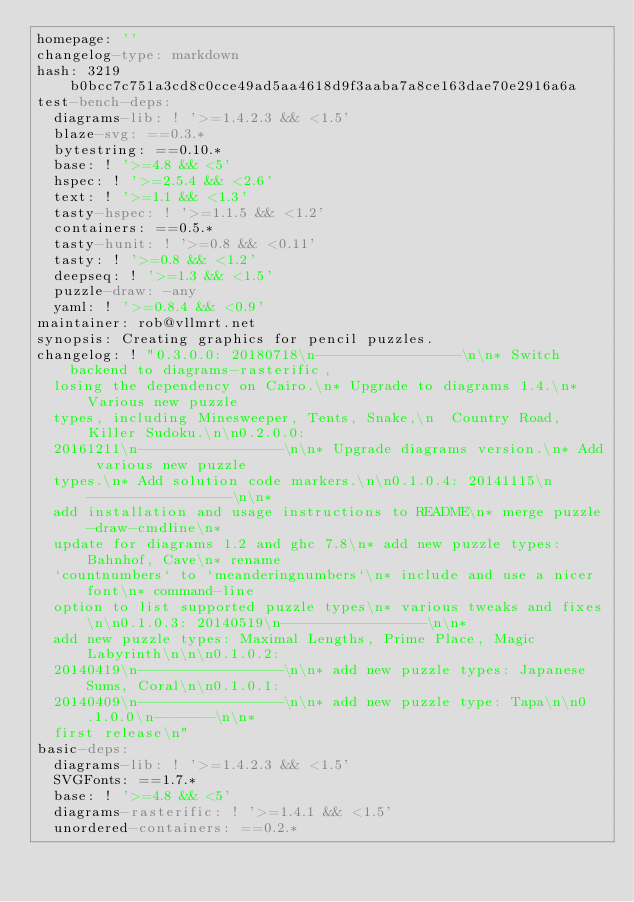Convert code to text. <code><loc_0><loc_0><loc_500><loc_500><_YAML_>homepage: ''
changelog-type: markdown
hash: 3219b0bcc7c751a3cd8c0cce49ad5aa4618d9f3aaba7a8ce163dae70e2916a6a
test-bench-deps:
  diagrams-lib: ! '>=1.4.2.3 && <1.5'
  blaze-svg: ==0.3.*
  bytestring: ==0.10.*
  base: ! '>=4.8 && <5'
  hspec: ! '>=2.5.4 && <2.6'
  text: ! '>=1.1 && <1.3'
  tasty-hspec: ! '>=1.1.5 && <1.2'
  containers: ==0.5.*
  tasty-hunit: ! '>=0.8 && <0.11'
  tasty: ! '>=0.8 && <1.2'
  deepseq: ! '>=1.3 && <1.5'
  puzzle-draw: -any
  yaml: ! '>=0.8.4 && <0.9'
maintainer: rob@vllmrt.net
synopsis: Creating graphics for pencil puzzles.
changelog: ! "0.3.0.0: 20180718\n-----------------\n\n* Switch backend to diagrams-rasterific,
  losing the dependency on Cairo.\n* Upgrade to diagrams 1.4.\n* Various new puzzle
  types, including Minesweeper, Tents, Snake,\n  Country Road, Killer Sudoku.\n\n0.2.0.0:
  20161211\n-----------------\n\n* Upgrade diagrams version.\n* Add various new puzzle
  types.\n* Add solution code markers.\n\n0.1.0.4: 20141115\n-----------------\n\n*
  add installation and usage instructions to README\n* merge puzzle-draw-cmdline\n*
  update for diagrams 1.2 and ghc 7.8\n* add new puzzle types: Bahnhof, Cave\n* rename
  `countnumbers` to `meanderingnumbers`\n* include and use a nicer font\n* command-line
  option to list supported puzzle types\n* various tweaks and fixes\n\n0.1.0.3: 20140519\n-----------------\n\n*
  add new puzzle types: Maximal Lengths, Prime Place, Magic Labyrinth\n\n\n0.1.0.2:
  20140419\n-----------------\n\n* add new puzzle types: Japanese Sums, Coral\n\n0.1.0.1:
  20140409\n-----------------\n\n* add new puzzle type: Tapa\n\n0.1.0.0\n-------\n\n*
  first release\n"
basic-deps:
  diagrams-lib: ! '>=1.4.2.3 && <1.5'
  SVGFonts: ==1.7.*
  base: ! '>=4.8 && <5'
  diagrams-rasterific: ! '>=1.4.1 && <1.5'
  unordered-containers: ==0.2.*</code> 